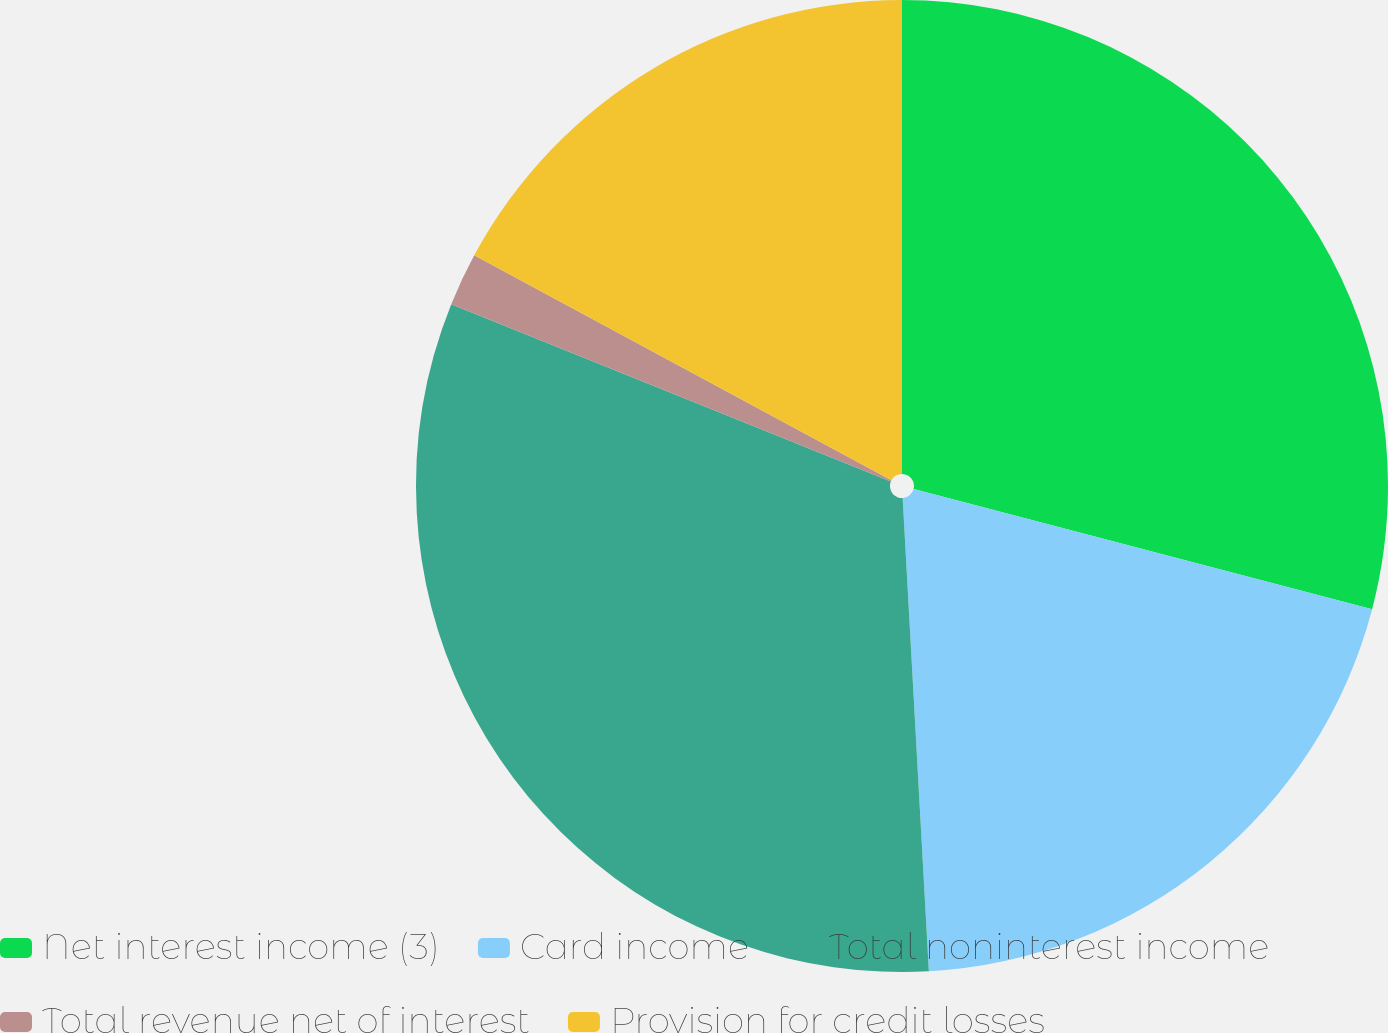Convert chart to OTSL. <chart><loc_0><loc_0><loc_500><loc_500><pie_chart><fcel>Net interest income (3)<fcel>Card income<fcel>Total noninterest income<fcel>Total revenue net of interest<fcel>Provision for credit losses<nl><fcel>29.08%<fcel>20.04%<fcel>31.98%<fcel>1.77%<fcel>17.13%<nl></chart> 